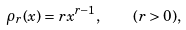Convert formula to latex. <formula><loc_0><loc_0><loc_500><loc_500>\rho _ { r } ( x ) = r x ^ { r - 1 } , \quad ( r > 0 ) ,</formula> 